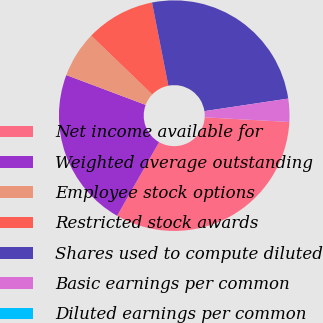Convert chart. <chart><loc_0><loc_0><loc_500><loc_500><pie_chart><fcel>Net income available for<fcel>Weighted average outstanding<fcel>Employee stock options<fcel>Restricted stock awards<fcel>Shares used to compute diluted<fcel>Basic earnings per common<fcel>Diluted earnings per common<nl><fcel>32.38%<fcel>22.48%<fcel>6.48%<fcel>9.71%<fcel>25.72%<fcel>3.24%<fcel>0.0%<nl></chart> 